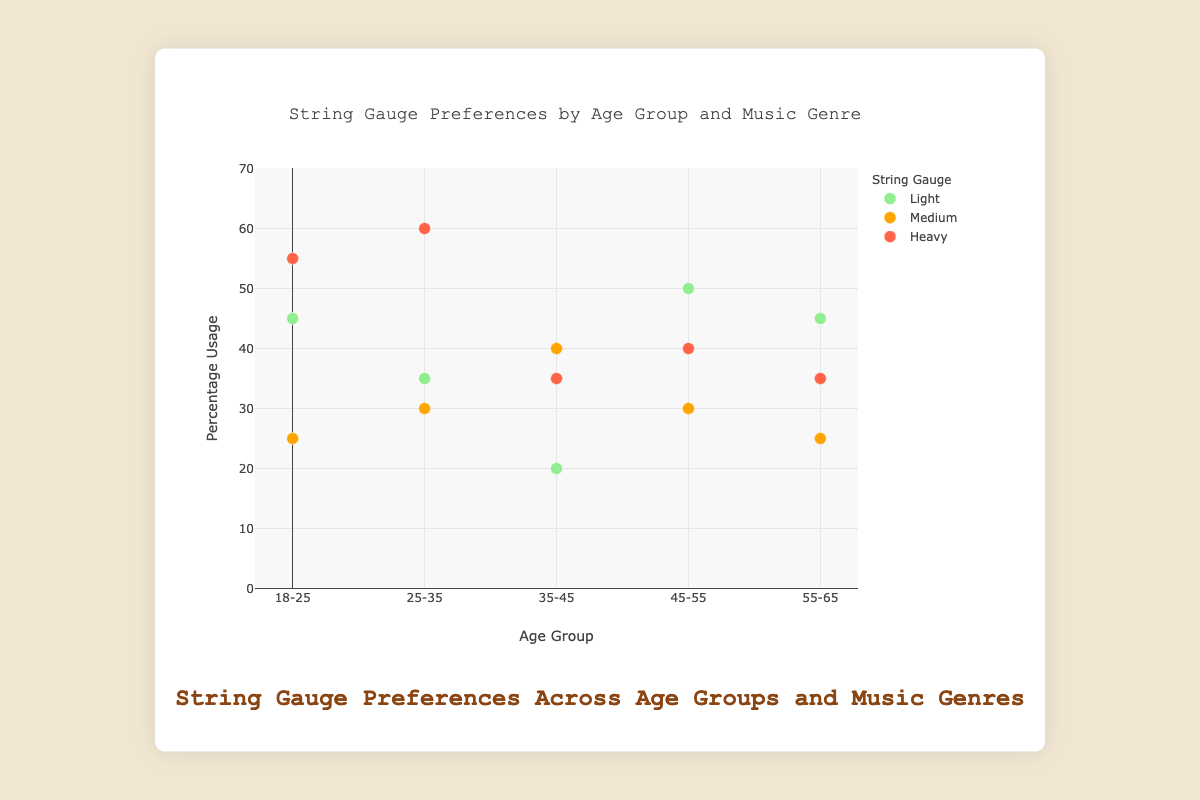What's the title of the chart? The title of the chart is located at the top center of the figure. According to the visualization, it reads "String Gauge Preferences by Age Group and Music Genre."
Answer: String Gauge Preferences by Age Group and Music Genre Which age group has the highest percentage usage for heavy gauge strings in Metal music? To find this, look at the data points related to Heavy gauge strings for the Metal music genre. The age group 25-35 has the highest percentage usage at 60%.
Answer: 25-35 How many age groups prefer light gauge strings for Jazz music? Check the data points for Jazz music indicated by the 'Light' string gauge color. There are two age groups: 35-45 and 45-55.
Answer: Two What's the average percentage usage of medium gauge strings across all age groups for Rock music? First, find the Rock music data points with medium gauge preferences: age groups 35-45 (40%) and 45-55 (30%). Add these percentages (40+30) and divide by the number of age groups (2). So, (40+30)/2 = 35%.
Answer: 35% Is the percentage usage for heavy gauge strings in Blues music higher for age group 35-45 or 45-55? Compare the data points for Blues music with heavy gauge usage in these two age groups. Age group 45-55 has a higher percentage usage (40%) compared to 35-45 (35%).
Answer: 45-55 Describe the trend of light gauge string use in relation to age. Inspect the data points of Light gauge strings across all age groups. As the age group increases from 18-25 to 55-65, the preference generally decreases except for a peak at 45-55.
Answer: Decreasing with age, peak at 45-55 Which music genre has the highest percentage usage of medium gauge strings in the 55-65 age group? Look at the medium gauge string data points for the 55-65 age group and their respective music genres. Classical is not present but Jazz is with 25%.
Answer: Jazz For the 18-25 age group, which string gauge is preferred the most for the Blues genre? Look at the 18-25 data points for Blues genre and check the string gauge preferences. The Medium gauge has the highest percentage usage (25%).
Answer: Medium Among all age groups, does any age group show a string gauge preference of over 50% for the Jazz genre? Check the Jazz genre data points and their percentage usage across all age groups. The 45-55 age group shows a 50% preference but not over it.
Answer: No, the highest is exactly 50% Which age group shows the highest variability in string gauge preferences across all music genres? Assess the percentage usage of all string gauges across different music genres for each age group. The 18-25 and 25-35 age groups show significant variations, but 18-25 differs more with Light (45%), Heavy (55%), and Medium (25%) preferences.
Answer: 18-25 